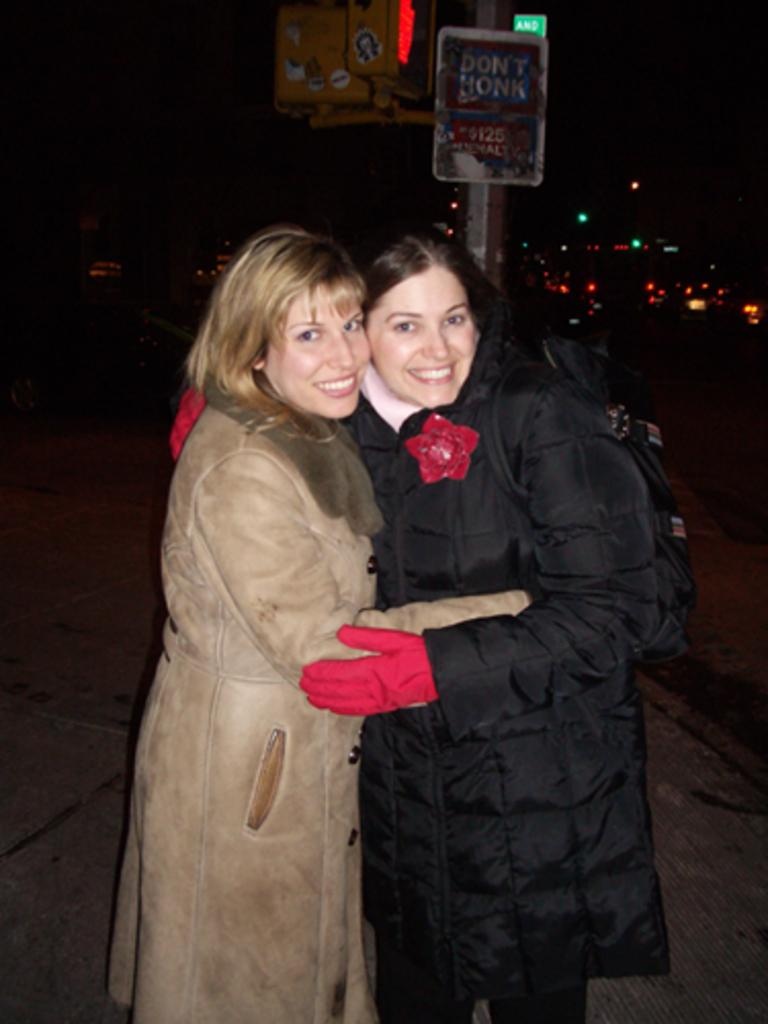How many women are in the image? There are two women standing in the front of the image. What can be seen in the background of the image? There is a sign board and lights in the background of the image. How would you describe the lighting conditions in the image? The background of the image is dark. What type of pear is being sold at the home in the image? There is no home or pear present in the image. 